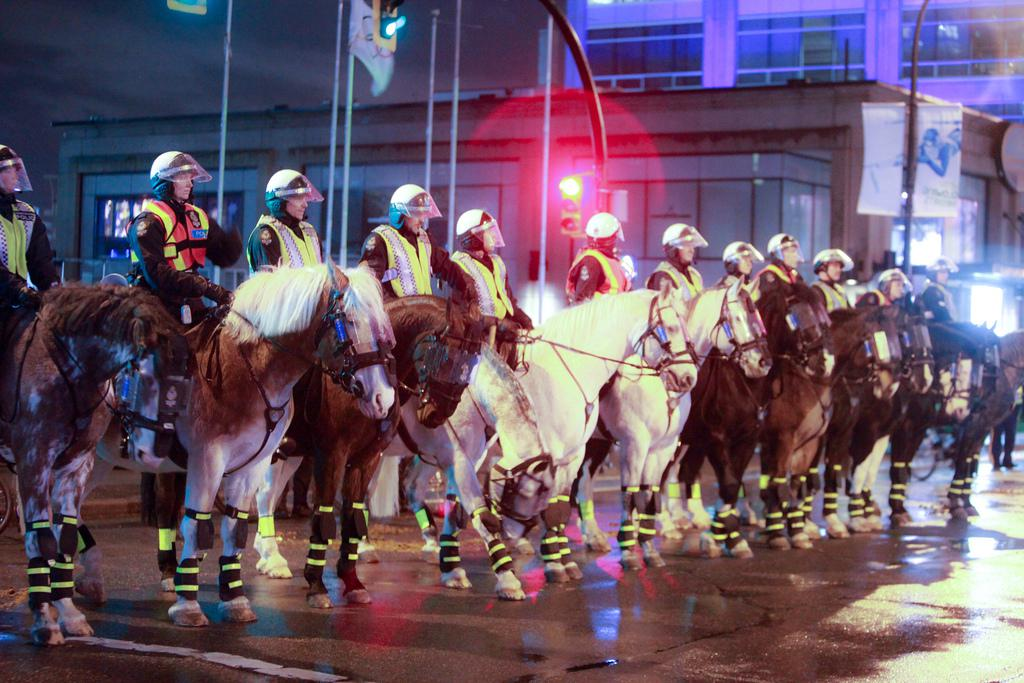Question: when was this picture taken?
Choices:
A. Day time.
B. Night time.
C. Noon.
D. Midnight.
Answer with the letter. Answer: B Question: what color are the horses?
Choices:
A. Black.
B. Tan.
C. Brown and white.
D. Yellow.
Answer with the letter. Answer: C Question: what are the men wearing on their heads?
Choices:
A. Helmets.
B. Baseball caps.
C. Beanies.
D. Wigs.
Answer with the letter. Answer: A Question: what are the men doing?
Choices:
A. Sitting on horses.
B. Riding to town.
C. Getting on ponies.
D. Waiting for the car to go by.
Answer with the letter. Answer: A Question: who is this a picture of?
Choices:
A. Firemen.
B. Rescue workers.
C. Doctors.
D. Police officers.
Answer with the letter. Answer: D Question: what colors are the horses?
Choices:
A. They are solid black.
B. They are red and tan.
C. They are brown and white.
D. They are solid white.
Answer with the letter. Answer: C Question: what have the horses worn?
Choices:
A. Safety equipment.
B. They have reflective yellow bands on their ankles.
C. Bridles.
D. Saddles.
Answer with the letter. Answer: B Question: where are the guards?
Choices:
A. Lined up on the side of the road.
B. They are lined up on their horses.
C. Near their horses.
D. On the parade route.
Answer with the letter. Answer: B Question: what is drawn on the grounds?
Choices:
A. Markings for the horse path.
B. A white is painted on the ground under the horse on the left.
C. A crosswalk.
D. Safety markers.
Answer with the letter. Answer: B Question: what is on the horses eyes?
Choices:
A. Eye protectors.
B. They have plastic shields over their eyes.
C. Blinders.
D. Blindfolds.
Answer with the letter. Answer: B Question: what is the color of the spotlight?
Choices:
A. Blue.
B. Red.
C. Yellow.
D. Green.
Answer with the letter. Answer: B Question: how are the men dressed?
Choices:
A. They are wearing helmets.
B. In army uniforms.
C. For construction work.
D. In football gear.
Answer with the letter. Answer: A Question: where was this picture taken?
Choices:
A. On the corner.
B. On the road.
C. On the street.
D. In front of the sign.
Answer with the letter. Answer: C Question: what are the men on the horses wearing?
Choices:
A. Jackets.
B. Shirts.
C. Vests.
D. Jerseys.
Answer with the letter. Answer: C Question: what is visible in the background?
Choices:
A. Trees.
B. A lake.
C. The windows of a building.
D. The shore.
Answer with the letter. Answer: C Question: what time of day is it?
Choices:
A. Evening.
B. Morning.
C. Night time.
D. Noon.
Answer with the letter. Answer: C Question: where is the building?
Choices:
A. By the house.
B. Near the garage.
C. In town.
D. Background.
Answer with the letter. Answer: D Question: what are the horses doing?
Choices:
A. Jumping.
B. Running.
C. Eating.
D. Standing still.
Answer with the letter. Answer: D Question: what keeps the rain off of the officer's faces?
Choices:
A. Sunglasses.
B. Their hand.
C. A building overhang.
D. Visor caps.
Answer with the letter. Answer: D 